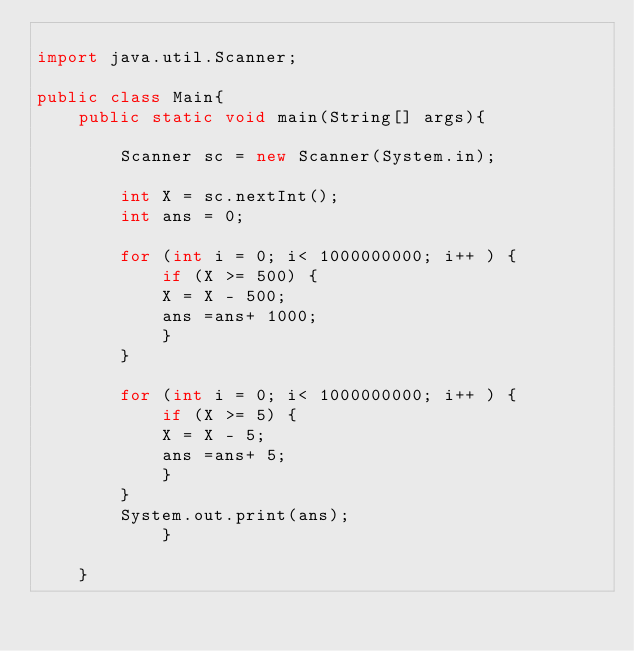<code> <loc_0><loc_0><loc_500><loc_500><_Java_>
import java.util.Scanner;

public class Main{
	public static void main(String[] args){

		Scanner sc = new Scanner(System.in);

		int X = sc.nextInt();
		int ans = 0;

		for (int i = 0; i< 1000000000; i++ ) {
			if (X >= 500) {
			X = X - 500;
			ans =ans+ 1000;
			}
		}

		for (int i = 0; i< 1000000000; i++ ) {
			if (X >= 5) {
			X = X - 5;
			ans =ans+ 5;
			}
		}
		System.out.print(ans);
			}

	}






</code> 